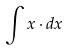<formula> <loc_0><loc_0><loc_500><loc_500>\int x \cdot d x</formula> 